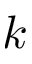<formula> <loc_0><loc_0><loc_500><loc_500>k</formula> 